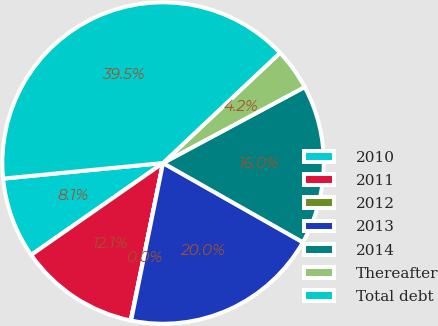<chart> <loc_0><loc_0><loc_500><loc_500><pie_chart><fcel>2010<fcel>2011<fcel>2012<fcel>2013<fcel>2014<fcel>Thereafter<fcel>Total debt<nl><fcel>8.14%<fcel>12.09%<fcel>0.04%<fcel>19.98%<fcel>16.04%<fcel>4.19%<fcel>39.52%<nl></chart> 